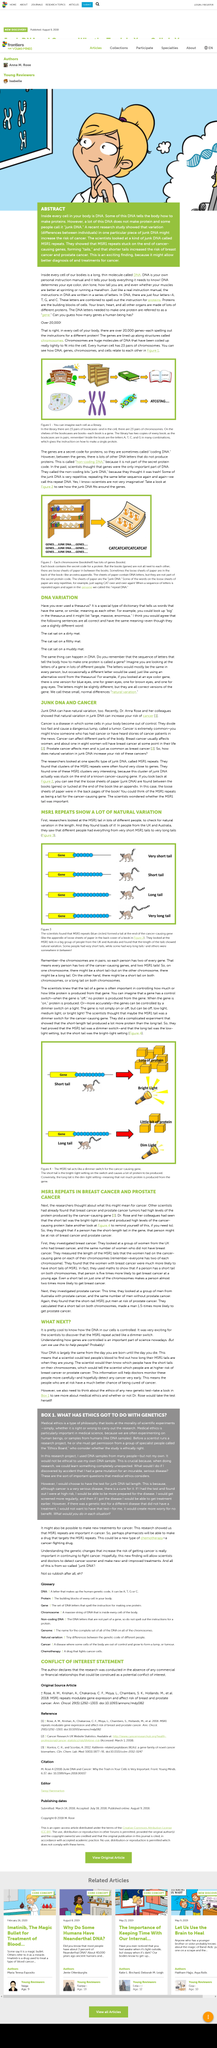Give some essential details in this illustration. Junk DNA is able to increase the risk of cancer due to its natural variation, which can lead to the development of cancer-causing genetic mutations. The MSR1 gene has a short tail characteristic. The woman in the image is contemplating the concept of DNA. Cancer has the potential to invade and affect various parts of the body. A study has found that the MSR1 gene can be detected in breast cancer and prostate cancer patients, suggesting that it may play a role in the development of these types of cancer. 